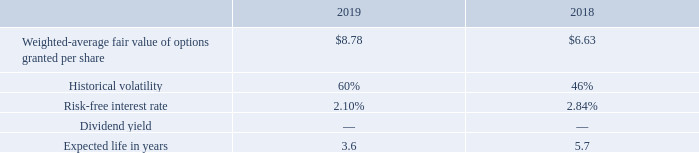The Company utilized the Black-Scholes option pricing model to value the stock options. The Company used an expected life as defined under the simplified method, which is using an average of the contractual term and vesting period of the stock options. The risk-free interest rate used for the award is based on the U.S. Treasury yield curve in effect at the time of grant. The Company accounted for forfeitures as they occur. The historical volatility was calculated based upon implied volatility of the Company's historical stock prices.
The fair value of 2019 and 2018 stock options was estimated using the Black-Scholes option pricing model with the following weighted-average assumptions:
As of December 31, 2019, there was approximately $419,000 of unrecognized stock-based compensation expense related to outstanding 2019 stock options, expected to be recognized over 3.4 and approximately $418,000 of unrecognized stock-based compensation expense related to outstanding 2018 stock options, expected to be recognized over 2.4 years. There was no unrecognized stock-based compensation expense relating stock options granted prior to 2018.
Which model did the company use to value the stock options? Black-scholes option pricing model. What is the historical volatility used in 2019 and 2018 respectively? 60%, 46%. What is the risk-free interest rate used in 2019 and 2018 respectively? 2.10%, 2.84%. What is the average risk-free interest rate used in 2018 and 2019?
Answer scale should be: percent. (2.10+ 2.84)/2
Answer: 2.47. What is the change in expected life in years used in the Black-Scholes model between 2018 and 2019? 3.6-5.7
Answer: -2.1. Which year has a higher weighted-average fair value of options granted per share used in the Black-Scholes model? Look at Row 2, and compare the values in COL3 and COL 4 to determine the answer
Answer: 2019. 